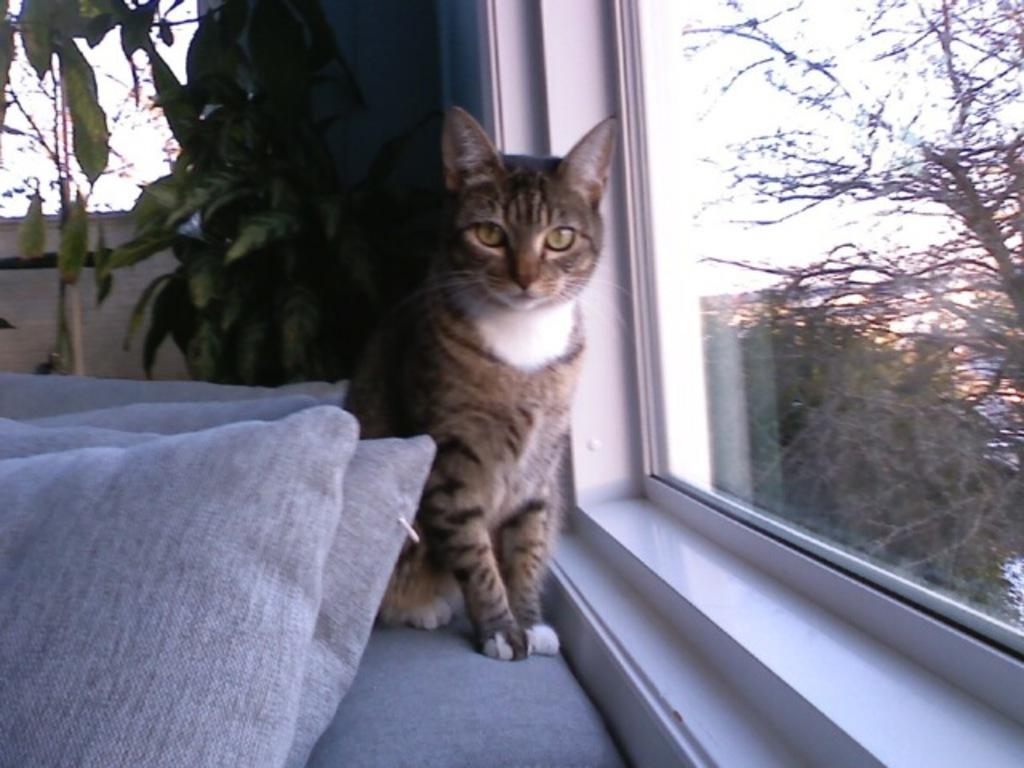Describe this image in one or two sentences. In this picture we can see a few pillows, plants and a few objects on the left side. We can see a cat. There is a glass object. Through this glass object, we can see a tree and other things on the right side. 